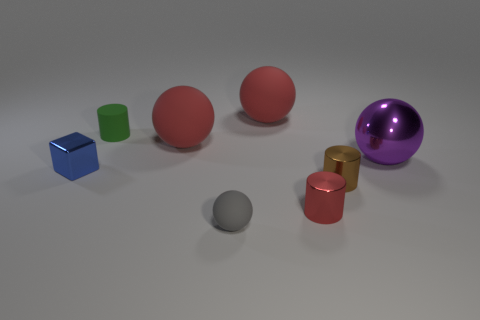There is a red thing in front of the purple sphere; what shape is it?
Give a very brief answer. Cylinder. Are there any large red rubber things that are behind the red sphere that is behind the tiny green matte cylinder?
Give a very brief answer. No. How many big purple spheres are the same material as the purple object?
Provide a short and direct response. 0. What is the size of the red rubber thing right of the large rubber thing that is in front of the cylinder behind the tiny brown cylinder?
Your response must be concise. Large. What number of tiny red metallic objects are on the left side of the red shiny thing?
Offer a terse response. 0. Is the number of brown matte cubes greater than the number of small rubber things?
Your answer should be very brief. No. What size is the red thing that is both in front of the green cylinder and on the left side of the red cylinder?
Make the answer very short. Large. The red ball that is to the left of the large sphere behind the cylinder that is behind the purple metal sphere is made of what material?
Provide a short and direct response. Rubber. Is the color of the object behind the tiny green cylinder the same as the large ball that is on the left side of the small rubber ball?
Your answer should be compact. Yes. There is a big rubber thing in front of the small matte thing that is behind the metallic object left of the tiny red cylinder; what is its shape?
Your answer should be compact. Sphere. 